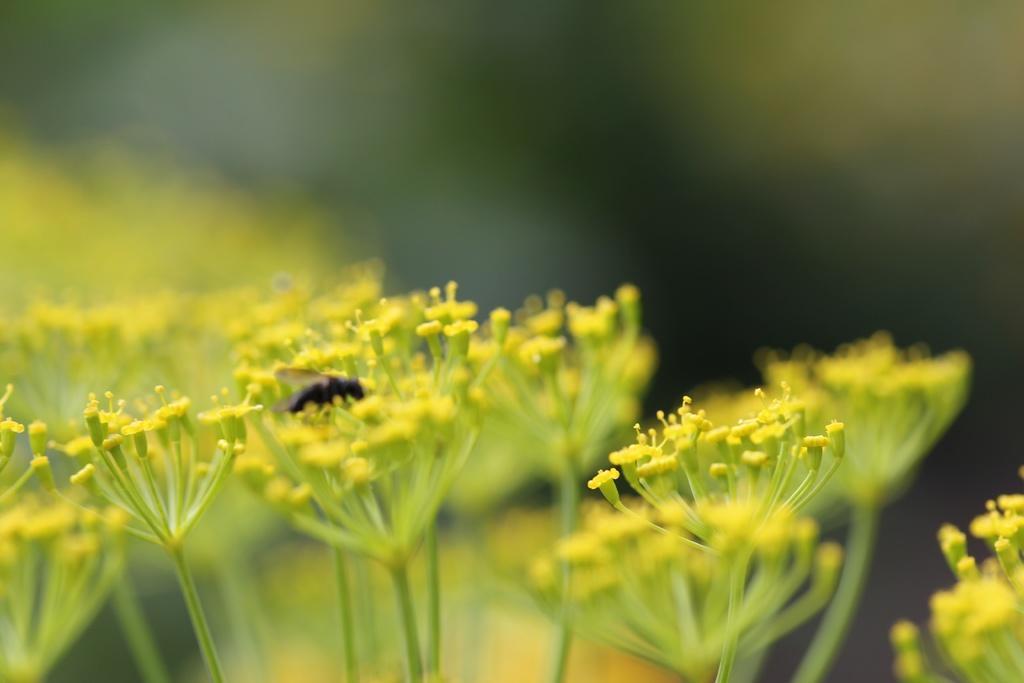Can you describe this image briefly? In the center of the image an insect is there. At the bottom of the image we can see flowers, plants. In the background the image is blur. 